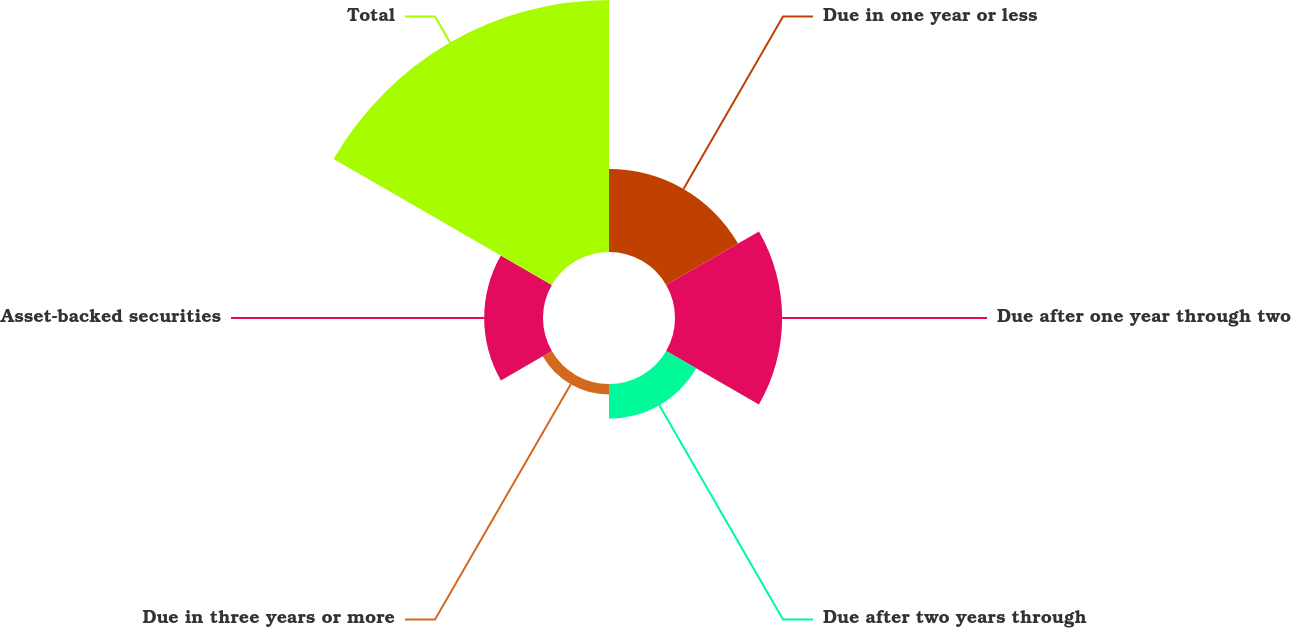Convert chart. <chart><loc_0><loc_0><loc_500><loc_500><pie_chart><fcel>Due in one year or less<fcel>Due after one year through two<fcel>Due after two years through<fcel>Due in three years or more<fcel>Asset-backed securities<fcel>Total<nl><fcel>15.19%<fcel>19.61%<fcel>6.35%<fcel>1.93%<fcel>10.77%<fcel>46.13%<nl></chart> 